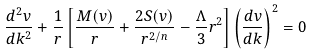Convert formula to latex. <formula><loc_0><loc_0><loc_500><loc_500>\frac { d ^ { 2 } v } { d k ^ { 2 } } + \frac { 1 } { r } \left [ \frac { M ( v ) } { r } + \frac { 2 S ( v ) } { r ^ { 2 / n } } - \frac { \Lambda } { 3 } r ^ { 2 } \right ] \left ( \frac { d v } { d k } \right ) ^ { 2 } = 0</formula> 